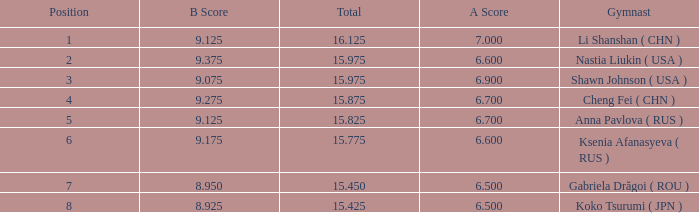Could you help me parse every detail presented in this table? {'header': ['Position', 'B Score', 'Total', 'A Score', 'Gymnast'], 'rows': [['1', '9.125', '16.125', '7.000', 'Li Shanshan ( CHN )'], ['2', '9.375', '15.975', '6.600', 'Nastia Liukin ( USA )'], ['3', '9.075', '15.975', '6.900', 'Shawn Johnson ( USA )'], ['4', '9.275', '15.875', '6.700', 'Cheng Fei ( CHN )'], ['5', '9.125', '15.825', '6.700', 'Anna Pavlova ( RUS )'], ['6', '9.175', '15.775', '6.600', 'Ksenia Afanasyeva ( RUS )'], ['7', '8.950', '15.450', '6.500', 'Gabriela Drăgoi ( ROU )'], ['8', '8.925', '15.425', '6.500', 'Koko Tsurumi ( JPN )']]} What the B Score when the total is 16.125 and the position is less than 7? 9.125. 